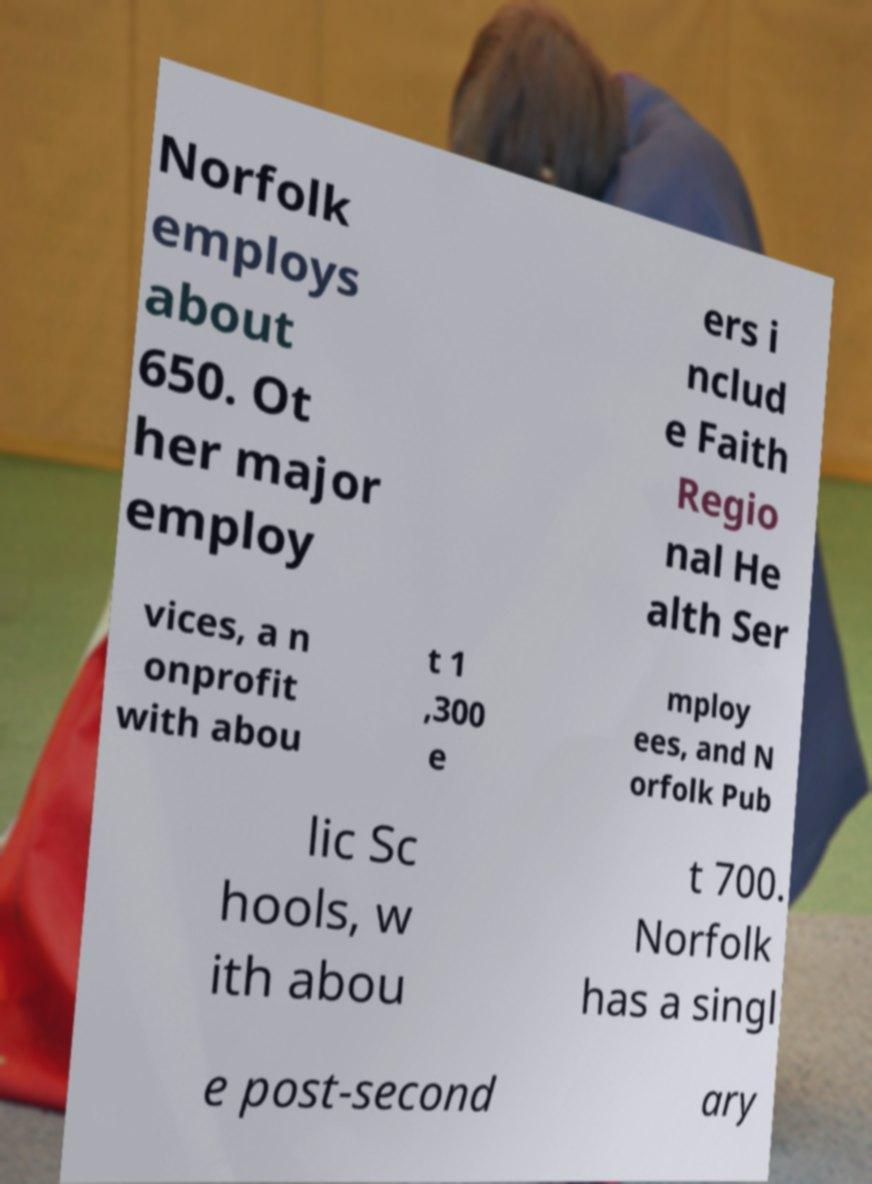What messages or text are displayed in this image? I need them in a readable, typed format. Norfolk employs about 650. Ot her major employ ers i nclud e Faith Regio nal He alth Ser vices, a n onprofit with abou t 1 ,300 e mploy ees, and N orfolk Pub lic Sc hools, w ith abou t 700. Norfolk has a singl e post-second ary 